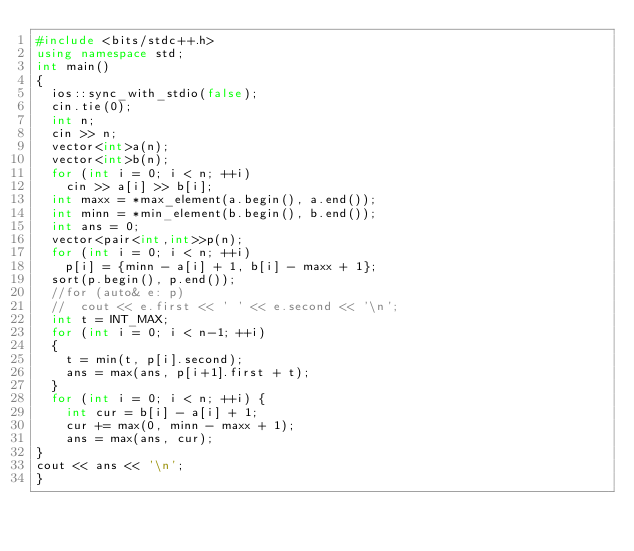<code> <loc_0><loc_0><loc_500><loc_500><_C++_>#include <bits/stdc++.h>
using namespace std;
int main()
{
  ios::sync_with_stdio(false);
  cin.tie(0);
  int n;
  cin >> n;
  vector<int>a(n);
  vector<int>b(n);
  for (int i = 0; i < n; ++i)
    cin >> a[i] >> b[i];
  int maxx = *max_element(a.begin(), a.end());
  int minn = *min_element(b.begin(), b.end());
  int ans = 0;
  vector<pair<int,int>>p(n);
  for (int i = 0; i < n; ++i) 
    p[i] = {minn - a[i] + 1, b[i] - maxx + 1};
  sort(p.begin(), p.end());
  //for (auto& e: p)
  //  cout << e.first << ' ' << e.second << '\n';
  int t = INT_MAX;
  for (int i = 0; i < n-1; ++i)
  {
    t = min(t, p[i].second);
    ans = max(ans, p[i+1].first + t);
  }
  for (int i = 0; i < n; ++i) {
    int cur = b[i] - a[i] + 1;
    cur += max(0, minn - maxx + 1);
    ans = max(ans, cur);
}
cout << ans << '\n';
}

</code> 